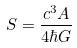Convert formula to latex. <formula><loc_0><loc_0><loc_500><loc_500>S = \frac { c ^ { 3 } A } { 4 \hbar { G } }</formula> 